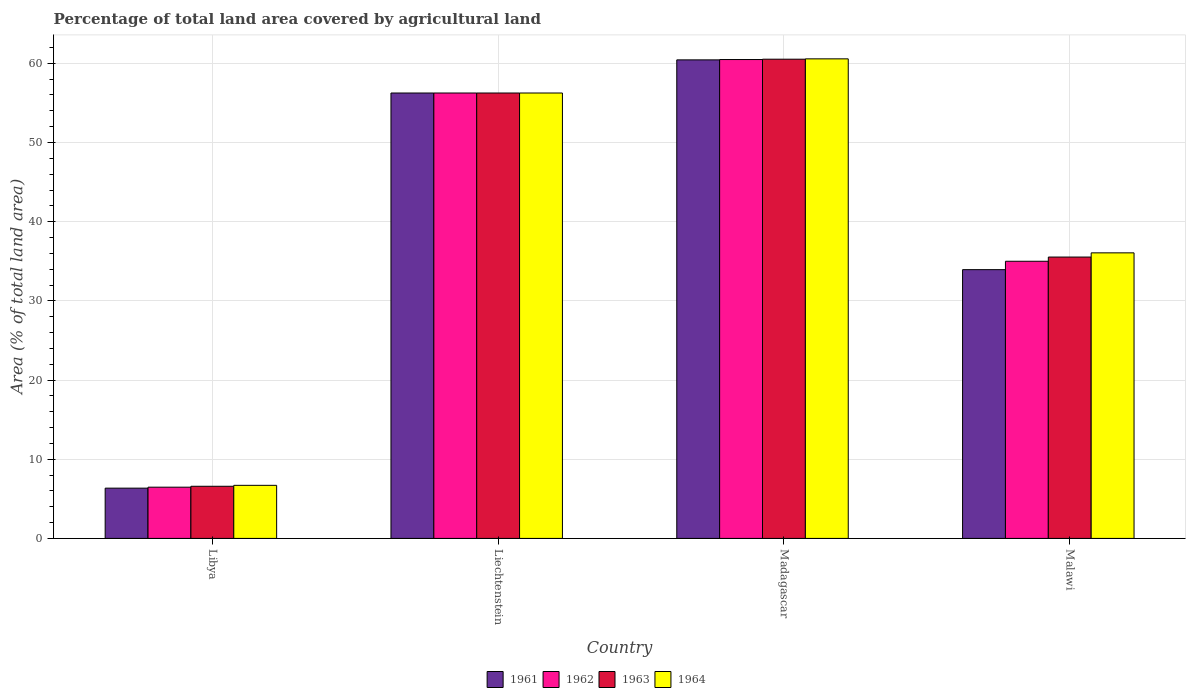Are the number of bars per tick equal to the number of legend labels?
Provide a short and direct response. Yes. Are the number of bars on each tick of the X-axis equal?
Your response must be concise. Yes. How many bars are there on the 2nd tick from the left?
Make the answer very short. 4. What is the label of the 3rd group of bars from the left?
Ensure brevity in your answer.  Madagascar. In how many cases, is the number of bars for a given country not equal to the number of legend labels?
Give a very brief answer. 0. What is the percentage of agricultural land in 1963 in Libya?
Keep it short and to the point. 6.58. Across all countries, what is the maximum percentage of agricultural land in 1963?
Offer a very short reply. 60.52. Across all countries, what is the minimum percentage of agricultural land in 1964?
Your answer should be compact. 6.7. In which country was the percentage of agricultural land in 1961 maximum?
Ensure brevity in your answer.  Madagascar. In which country was the percentage of agricultural land in 1964 minimum?
Your answer should be very brief. Libya. What is the total percentage of agricultural land in 1962 in the graph?
Offer a very short reply. 158.2. What is the difference between the percentage of agricultural land in 1964 in Libya and that in Liechtenstein?
Make the answer very short. -49.55. What is the difference between the percentage of agricultural land in 1962 in Malawi and the percentage of agricultural land in 1961 in Madagascar?
Keep it short and to the point. -25.43. What is the average percentage of agricultural land in 1964 per country?
Make the answer very short. 39.89. What is the difference between the percentage of agricultural land of/in 1964 and percentage of agricultural land of/in 1961 in Madagascar?
Offer a very short reply. 0.13. What is the ratio of the percentage of agricultural land in 1961 in Libya to that in Malawi?
Provide a succinct answer. 0.19. What is the difference between the highest and the second highest percentage of agricultural land in 1963?
Provide a succinct answer. 20.72. What is the difference between the highest and the lowest percentage of agricultural land in 1962?
Offer a terse response. 54.01. Is the sum of the percentage of agricultural land in 1964 in Liechtenstein and Malawi greater than the maximum percentage of agricultural land in 1963 across all countries?
Make the answer very short. Yes. Is it the case that in every country, the sum of the percentage of agricultural land in 1963 and percentage of agricultural land in 1962 is greater than the sum of percentage of agricultural land in 1961 and percentage of agricultural land in 1964?
Give a very brief answer. No. What does the 3rd bar from the left in Libya represents?
Provide a short and direct response. 1963. What does the 1st bar from the right in Madagascar represents?
Your response must be concise. 1964. How many bars are there?
Ensure brevity in your answer.  16. Are the values on the major ticks of Y-axis written in scientific E-notation?
Make the answer very short. No. Does the graph contain any zero values?
Give a very brief answer. No. Where does the legend appear in the graph?
Your answer should be compact. Bottom center. How many legend labels are there?
Offer a terse response. 4. What is the title of the graph?
Give a very brief answer. Percentage of total land area covered by agricultural land. Does "1999" appear as one of the legend labels in the graph?
Your answer should be very brief. No. What is the label or title of the Y-axis?
Provide a short and direct response. Area (% of total land area). What is the Area (% of total land area) in 1961 in Libya?
Your answer should be very brief. 6.35. What is the Area (% of total land area) in 1962 in Libya?
Provide a short and direct response. 6.47. What is the Area (% of total land area) in 1963 in Libya?
Your response must be concise. 6.58. What is the Area (% of total land area) of 1964 in Libya?
Your answer should be compact. 6.7. What is the Area (% of total land area) in 1961 in Liechtenstein?
Provide a short and direct response. 56.25. What is the Area (% of total land area) in 1962 in Liechtenstein?
Your answer should be very brief. 56.25. What is the Area (% of total land area) of 1963 in Liechtenstein?
Your answer should be very brief. 56.25. What is the Area (% of total land area) in 1964 in Liechtenstein?
Provide a succinct answer. 56.25. What is the Area (% of total land area) of 1961 in Madagascar?
Your answer should be compact. 60.43. What is the Area (% of total land area) in 1962 in Madagascar?
Make the answer very short. 60.48. What is the Area (% of total land area) of 1963 in Madagascar?
Your answer should be very brief. 60.52. What is the Area (% of total land area) of 1964 in Madagascar?
Your answer should be compact. 60.56. What is the Area (% of total land area) in 1961 in Malawi?
Give a very brief answer. 33.94. What is the Area (% of total land area) of 1962 in Malawi?
Your answer should be compact. 35. What is the Area (% of total land area) of 1963 in Malawi?
Your answer should be very brief. 35.53. What is the Area (% of total land area) in 1964 in Malawi?
Your response must be concise. 36.06. Across all countries, what is the maximum Area (% of total land area) in 1961?
Offer a very short reply. 60.43. Across all countries, what is the maximum Area (% of total land area) in 1962?
Offer a terse response. 60.48. Across all countries, what is the maximum Area (% of total land area) in 1963?
Offer a very short reply. 60.52. Across all countries, what is the maximum Area (% of total land area) of 1964?
Offer a terse response. 60.56. Across all countries, what is the minimum Area (% of total land area) of 1961?
Offer a terse response. 6.35. Across all countries, what is the minimum Area (% of total land area) in 1962?
Offer a terse response. 6.47. Across all countries, what is the minimum Area (% of total land area) of 1963?
Keep it short and to the point. 6.58. Across all countries, what is the minimum Area (% of total land area) of 1964?
Ensure brevity in your answer.  6.7. What is the total Area (% of total land area) of 1961 in the graph?
Your response must be concise. 156.97. What is the total Area (% of total land area) of 1962 in the graph?
Provide a succinct answer. 158.2. What is the total Area (% of total land area) of 1963 in the graph?
Your response must be concise. 158.89. What is the total Area (% of total land area) of 1964 in the graph?
Give a very brief answer. 159.58. What is the difference between the Area (% of total land area) of 1961 in Libya and that in Liechtenstein?
Offer a terse response. -49.9. What is the difference between the Area (% of total land area) of 1962 in Libya and that in Liechtenstein?
Your response must be concise. -49.78. What is the difference between the Area (% of total land area) of 1963 in Libya and that in Liechtenstein?
Keep it short and to the point. -49.67. What is the difference between the Area (% of total land area) in 1964 in Libya and that in Liechtenstein?
Your response must be concise. -49.55. What is the difference between the Area (% of total land area) in 1961 in Libya and that in Madagascar?
Keep it short and to the point. -54.09. What is the difference between the Area (% of total land area) in 1962 in Libya and that in Madagascar?
Your answer should be compact. -54.01. What is the difference between the Area (% of total land area) in 1963 in Libya and that in Madagascar?
Keep it short and to the point. -53.94. What is the difference between the Area (% of total land area) in 1964 in Libya and that in Madagascar?
Keep it short and to the point. -53.86. What is the difference between the Area (% of total land area) of 1961 in Libya and that in Malawi?
Provide a succinct answer. -27.59. What is the difference between the Area (% of total land area) in 1962 in Libya and that in Malawi?
Make the answer very short. -28.53. What is the difference between the Area (% of total land area) of 1963 in Libya and that in Malawi?
Provide a succinct answer. -28.95. What is the difference between the Area (% of total land area) in 1964 in Libya and that in Malawi?
Your response must be concise. -29.36. What is the difference between the Area (% of total land area) in 1961 in Liechtenstein and that in Madagascar?
Your answer should be compact. -4.18. What is the difference between the Area (% of total land area) of 1962 in Liechtenstein and that in Madagascar?
Your answer should be very brief. -4.23. What is the difference between the Area (% of total land area) of 1963 in Liechtenstein and that in Madagascar?
Provide a short and direct response. -4.27. What is the difference between the Area (% of total land area) of 1964 in Liechtenstein and that in Madagascar?
Make the answer very short. -4.31. What is the difference between the Area (% of total land area) of 1961 in Liechtenstein and that in Malawi?
Give a very brief answer. 22.31. What is the difference between the Area (% of total land area) of 1962 in Liechtenstein and that in Malawi?
Give a very brief answer. 21.25. What is the difference between the Area (% of total land area) in 1963 in Liechtenstein and that in Malawi?
Make the answer very short. 20.72. What is the difference between the Area (% of total land area) of 1964 in Liechtenstein and that in Malawi?
Provide a short and direct response. 20.19. What is the difference between the Area (% of total land area) of 1961 in Madagascar and that in Malawi?
Offer a terse response. 26.49. What is the difference between the Area (% of total land area) in 1962 in Madagascar and that in Malawi?
Make the answer very short. 25.48. What is the difference between the Area (% of total land area) in 1963 in Madagascar and that in Malawi?
Your answer should be very brief. 24.99. What is the difference between the Area (% of total land area) in 1964 in Madagascar and that in Malawi?
Your answer should be compact. 24.5. What is the difference between the Area (% of total land area) in 1961 in Libya and the Area (% of total land area) in 1962 in Liechtenstein?
Ensure brevity in your answer.  -49.9. What is the difference between the Area (% of total land area) of 1961 in Libya and the Area (% of total land area) of 1963 in Liechtenstein?
Offer a terse response. -49.9. What is the difference between the Area (% of total land area) in 1961 in Libya and the Area (% of total land area) in 1964 in Liechtenstein?
Make the answer very short. -49.9. What is the difference between the Area (% of total land area) in 1962 in Libya and the Area (% of total land area) in 1963 in Liechtenstein?
Offer a terse response. -49.78. What is the difference between the Area (% of total land area) of 1962 in Libya and the Area (% of total land area) of 1964 in Liechtenstein?
Provide a short and direct response. -49.78. What is the difference between the Area (% of total land area) in 1963 in Libya and the Area (% of total land area) in 1964 in Liechtenstein?
Provide a short and direct response. -49.67. What is the difference between the Area (% of total land area) in 1961 in Libya and the Area (% of total land area) in 1962 in Madagascar?
Ensure brevity in your answer.  -54.13. What is the difference between the Area (% of total land area) of 1961 in Libya and the Area (% of total land area) of 1963 in Madagascar?
Your answer should be compact. -54.17. What is the difference between the Area (% of total land area) in 1961 in Libya and the Area (% of total land area) in 1964 in Madagascar?
Your answer should be compact. -54.22. What is the difference between the Area (% of total land area) in 1962 in Libya and the Area (% of total land area) in 1963 in Madagascar?
Offer a very short reply. -54.05. What is the difference between the Area (% of total land area) of 1962 in Libya and the Area (% of total land area) of 1964 in Madagascar?
Give a very brief answer. -54.09. What is the difference between the Area (% of total land area) of 1963 in Libya and the Area (% of total land area) of 1964 in Madagascar?
Make the answer very short. -53.98. What is the difference between the Area (% of total land area) in 1961 in Libya and the Area (% of total land area) in 1962 in Malawi?
Keep it short and to the point. -28.65. What is the difference between the Area (% of total land area) in 1961 in Libya and the Area (% of total land area) in 1963 in Malawi?
Offer a terse response. -29.18. What is the difference between the Area (% of total land area) in 1961 in Libya and the Area (% of total land area) in 1964 in Malawi?
Keep it short and to the point. -29.71. What is the difference between the Area (% of total land area) of 1962 in Libya and the Area (% of total land area) of 1963 in Malawi?
Offer a very short reply. -29.06. What is the difference between the Area (% of total land area) in 1962 in Libya and the Area (% of total land area) in 1964 in Malawi?
Your answer should be very brief. -29.59. What is the difference between the Area (% of total land area) of 1963 in Libya and the Area (% of total land area) of 1964 in Malawi?
Offer a very short reply. -29.48. What is the difference between the Area (% of total land area) of 1961 in Liechtenstein and the Area (% of total land area) of 1962 in Madagascar?
Give a very brief answer. -4.23. What is the difference between the Area (% of total land area) of 1961 in Liechtenstein and the Area (% of total land area) of 1963 in Madagascar?
Keep it short and to the point. -4.27. What is the difference between the Area (% of total land area) in 1961 in Liechtenstein and the Area (% of total land area) in 1964 in Madagascar?
Ensure brevity in your answer.  -4.31. What is the difference between the Area (% of total land area) in 1962 in Liechtenstein and the Area (% of total land area) in 1963 in Madagascar?
Make the answer very short. -4.27. What is the difference between the Area (% of total land area) in 1962 in Liechtenstein and the Area (% of total land area) in 1964 in Madagascar?
Your response must be concise. -4.31. What is the difference between the Area (% of total land area) in 1963 in Liechtenstein and the Area (% of total land area) in 1964 in Madagascar?
Provide a succinct answer. -4.31. What is the difference between the Area (% of total land area) in 1961 in Liechtenstein and the Area (% of total land area) in 1962 in Malawi?
Offer a terse response. 21.25. What is the difference between the Area (% of total land area) of 1961 in Liechtenstein and the Area (% of total land area) of 1963 in Malawi?
Your answer should be compact. 20.72. What is the difference between the Area (% of total land area) of 1961 in Liechtenstein and the Area (% of total land area) of 1964 in Malawi?
Your answer should be very brief. 20.19. What is the difference between the Area (% of total land area) of 1962 in Liechtenstein and the Area (% of total land area) of 1963 in Malawi?
Make the answer very short. 20.72. What is the difference between the Area (% of total land area) in 1962 in Liechtenstein and the Area (% of total land area) in 1964 in Malawi?
Offer a very short reply. 20.19. What is the difference between the Area (% of total land area) of 1963 in Liechtenstein and the Area (% of total land area) of 1964 in Malawi?
Keep it short and to the point. 20.19. What is the difference between the Area (% of total land area) in 1961 in Madagascar and the Area (% of total land area) in 1962 in Malawi?
Provide a short and direct response. 25.43. What is the difference between the Area (% of total land area) in 1961 in Madagascar and the Area (% of total land area) in 1963 in Malawi?
Keep it short and to the point. 24.9. What is the difference between the Area (% of total land area) of 1961 in Madagascar and the Area (% of total land area) of 1964 in Malawi?
Offer a very short reply. 24.37. What is the difference between the Area (% of total land area) in 1962 in Madagascar and the Area (% of total land area) in 1963 in Malawi?
Make the answer very short. 24.94. What is the difference between the Area (% of total land area) of 1962 in Madagascar and the Area (% of total land area) of 1964 in Malawi?
Your answer should be compact. 24.41. What is the difference between the Area (% of total land area) of 1963 in Madagascar and the Area (% of total land area) of 1964 in Malawi?
Provide a succinct answer. 24.46. What is the average Area (% of total land area) of 1961 per country?
Give a very brief answer. 39.24. What is the average Area (% of total land area) in 1962 per country?
Your answer should be very brief. 39.55. What is the average Area (% of total land area) in 1963 per country?
Your answer should be compact. 39.72. What is the average Area (% of total land area) of 1964 per country?
Offer a terse response. 39.89. What is the difference between the Area (% of total land area) of 1961 and Area (% of total land area) of 1962 in Libya?
Your response must be concise. -0.12. What is the difference between the Area (% of total land area) in 1961 and Area (% of total land area) in 1963 in Libya?
Your response must be concise. -0.24. What is the difference between the Area (% of total land area) in 1961 and Area (% of total land area) in 1964 in Libya?
Your response must be concise. -0.35. What is the difference between the Area (% of total land area) in 1962 and Area (% of total land area) in 1963 in Libya?
Your answer should be compact. -0.11. What is the difference between the Area (% of total land area) of 1962 and Area (% of total land area) of 1964 in Libya?
Keep it short and to the point. -0.23. What is the difference between the Area (% of total land area) of 1963 and Area (% of total land area) of 1964 in Libya?
Provide a short and direct response. -0.12. What is the difference between the Area (% of total land area) of 1961 and Area (% of total land area) of 1963 in Liechtenstein?
Ensure brevity in your answer.  0. What is the difference between the Area (% of total land area) of 1961 and Area (% of total land area) of 1964 in Liechtenstein?
Provide a succinct answer. 0. What is the difference between the Area (% of total land area) of 1962 and Area (% of total land area) of 1963 in Liechtenstein?
Offer a very short reply. 0. What is the difference between the Area (% of total land area) of 1963 and Area (% of total land area) of 1964 in Liechtenstein?
Ensure brevity in your answer.  0. What is the difference between the Area (% of total land area) in 1961 and Area (% of total land area) in 1962 in Madagascar?
Your response must be concise. -0.04. What is the difference between the Area (% of total land area) of 1961 and Area (% of total land area) of 1963 in Madagascar?
Your answer should be compact. -0.09. What is the difference between the Area (% of total land area) in 1961 and Area (% of total land area) in 1964 in Madagascar?
Your answer should be very brief. -0.13. What is the difference between the Area (% of total land area) in 1962 and Area (% of total land area) in 1963 in Madagascar?
Your answer should be very brief. -0.04. What is the difference between the Area (% of total land area) in 1962 and Area (% of total land area) in 1964 in Madagascar?
Your answer should be very brief. -0.09. What is the difference between the Area (% of total land area) in 1963 and Area (% of total land area) in 1964 in Madagascar?
Make the answer very short. -0.04. What is the difference between the Area (% of total land area) in 1961 and Area (% of total land area) in 1962 in Malawi?
Ensure brevity in your answer.  -1.06. What is the difference between the Area (% of total land area) in 1961 and Area (% of total land area) in 1963 in Malawi?
Your response must be concise. -1.59. What is the difference between the Area (% of total land area) of 1961 and Area (% of total land area) of 1964 in Malawi?
Your answer should be very brief. -2.12. What is the difference between the Area (% of total land area) of 1962 and Area (% of total land area) of 1963 in Malawi?
Provide a short and direct response. -0.53. What is the difference between the Area (% of total land area) of 1962 and Area (% of total land area) of 1964 in Malawi?
Your response must be concise. -1.06. What is the difference between the Area (% of total land area) of 1963 and Area (% of total land area) of 1964 in Malawi?
Your answer should be compact. -0.53. What is the ratio of the Area (% of total land area) of 1961 in Libya to that in Liechtenstein?
Your response must be concise. 0.11. What is the ratio of the Area (% of total land area) of 1962 in Libya to that in Liechtenstein?
Offer a very short reply. 0.12. What is the ratio of the Area (% of total land area) of 1963 in Libya to that in Liechtenstein?
Provide a short and direct response. 0.12. What is the ratio of the Area (% of total land area) of 1964 in Libya to that in Liechtenstein?
Provide a short and direct response. 0.12. What is the ratio of the Area (% of total land area) of 1961 in Libya to that in Madagascar?
Offer a very short reply. 0.1. What is the ratio of the Area (% of total land area) of 1962 in Libya to that in Madagascar?
Your response must be concise. 0.11. What is the ratio of the Area (% of total land area) in 1963 in Libya to that in Madagascar?
Your answer should be compact. 0.11. What is the ratio of the Area (% of total land area) of 1964 in Libya to that in Madagascar?
Your answer should be very brief. 0.11. What is the ratio of the Area (% of total land area) in 1961 in Libya to that in Malawi?
Give a very brief answer. 0.19. What is the ratio of the Area (% of total land area) in 1962 in Libya to that in Malawi?
Keep it short and to the point. 0.18. What is the ratio of the Area (% of total land area) in 1963 in Libya to that in Malawi?
Provide a short and direct response. 0.19. What is the ratio of the Area (% of total land area) in 1964 in Libya to that in Malawi?
Keep it short and to the point. 0.19. What is the ratio of the Area (% of total land area) in 1961 in Liechtenstein to that in Madagascar?
Ensure brevity in your answer.  0.93. What is the ratio of the Area (% of total land area) in 1962 in Liechtenstein to that in Madagascar?
Your answer should be compact. 0.93. What is the ratio of the Area (% of total land area) in 1963 in Liechtenstein to that in Madagascar?
Your answer should be very brief. 0.93. What is the ratio of the Area (% of total land area) in 1964 in Liechtenstein to that in Madagascar?
Provide a short and direct response. 0.93. What is the ratio of the Area (% of total land area) of 1961 in Liechtenstein to that in Malawi?
Your answer should be very brief. 1.66. What is the ratio of the Area (% of total land area) of 1962 in Liechtenstein to that in Malawi?
Offer a very short reply. 1.61. What is the ratio of the Area (% of total land area) of 1963 in Liechtenstein to that in Malawi?
Provide a succinct answer. 1.58. What is the ratio of the Area (% of total land area) in 1964 in Liechtenstein to that in Malawi?
Ensure brevity in your answer.  1.56. What is the ratio of the Area (% of total land area) in 1961 in Madagascar to that in Malawi?
Offer a very short reply. 1.78. What is the ratio of the Area (% of total land area) of 1962 in Madagascar to that in Malawi?
Provide a short and direct response. 1.73. What is the ratio of the Area (% of total land area) of 1963 in Madagascar to that in Malawi?
Provide a succinct answer. 1.7. What is the ratio of the Area (% of total land area) in 1964 in Madagascar to that in Malawi?
Make the answer very short. 1.68. What is the difference between the highest and the second highest Area (% of total land area) in 1961?
Offer a terse response. 4.18. What is the difference between the highest and the second highest Area (% of total land area) of 1962?
Keep it short and to the point. 4.23. What is the difference between the highest and the second highest Area (% of total land area) of 1963?
Offer a terse response. 4.27. What is the difference between the highest and the second highest Area (% of total land area) of 1964?
Your answer should be very brief. 4.31. What is the difference between the highest and the lowest Area (% of total land area) of 1961?
Provide a succinct answer. 54.09. What is the difference between the highest and the lowest Area (% of total land area) of 1962?
Keep it short and to the point. 54.01. What is the difference between the highest and the lowest Area (% of total land area) of 1963?
Your answer should be very brief. 53.94. What is the difference between the highest and the lowest Area (% of total land area) of 1964?
Keep it short and to the point. 53.86. 